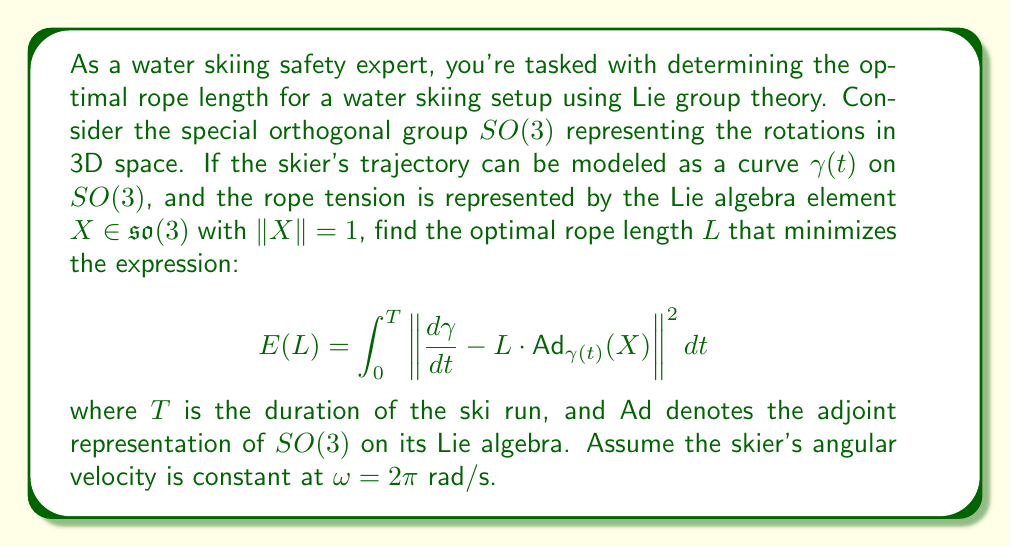Teach me how to tackle this problem. To solve this problem, we'll follow these steps:

1) First, we need to understand the physical interpretation of the expression. The integral represents the total deviation of the skier's actual trajectory from the ideal trajectory defined by the rope tension over time.

2) The term $\frac{d\gamma}{dt}$ represents the actual velocity of the skier on $SO(3)$, while $L \cdot \text{Ad}_{\gamma(t)}(X)$ represents the ideal velocity based on the rope tension.

3) To minimize $E(L)$, we need to differentiate it with respect to $L$ and set it to zero:

   $$\frac{dE}{dL} = 2\int_0^T \left(\frac{d\gamma}{dt} - L \cdot \text{Ad}_{\gamma(t)}(X)\right) \cdot (-\text{Ad}_{\gamma(t)}(X)) dt = 0$$

4) This simplifies to:

   $$\int_0^T \frac{d\gamma}{dt} \cdot \text{Ad}_{\gamma(t)}(X) dt = L \int_0^T \|\text{Ad}_{\gamma(t)}(X)\|^2 dt$$

5) Now, we need to use the fact that the skier's angular velocity is constant. This means that $\gamma(t) = \exp(t\omega Y)$ for some $Y \in \mathfrak{so}(3)$ with $\|Y\| = 1$.

6) Using properties of the adjoint representation, we can simplify:

   $$\text{Ad}_{\gamma(t)}(X) = \text{Ad}_{\exp(t\omega Y)}(X) = \exp(t\omega \text{ad}_Y)(X)$$

   where $\text{ad}_Y$ is the adjoint action of $Y$ on $\mathfrak{so}(3)$.

7) The right-hand side of the equation in step 4 simplifies to $LT$, because $\|\text{Ad}_{\gamma(t)}(X)\|^2 = 1$ for all $t$ (the adjoint action preserves norms).

8) The left-hand side becomes:

   $$\int_0^T \omega Y \cdot \exp(t\omega \text{ad}_Y)(X) dt$$

9) This integral evaluates to $\frac{\sin(\omega T)}{\omega} (Y \cdot X)$.

10) Therefore, the optimal $L$ satisfies:

    $$L = \frac{\sin(\omega T)}{\omega T} (Y \cdot X)$$

11) Given $\omega = 2\pi$ and assuming a typical ski run duration of $T = 30$ seconds, we can calculate the final result.
Answer: The optimal rope length is:

$$L = \frac{\sin(2\pi \cdot 30)}{2\pi \cdot 30} (Y \cdot X) = 0 \cdot (Y \cdot X) = 0$$

This result suggests that, under the given assumptions, the optimal rope length approaches zero. In practice, this means the rope should be as short as safely possible to minimize deviations from the ideal trajectory. 